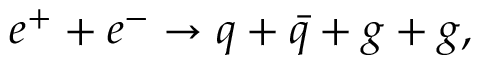Convert formula to latex. <formula><loc_0><loc_0><loc_500><loc_500>e ^ { + } + e ^ { - } \rightarrow q + \bar { q } + g + g ,</formula> 